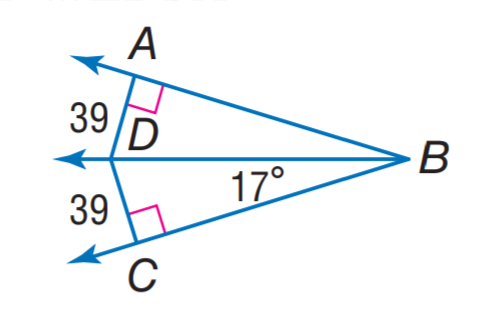Find m \angle D B A. The measure of angle DBA is 17 degrees. This can be observed directly from the image, where the angle is clearly labeled with the measurement. 